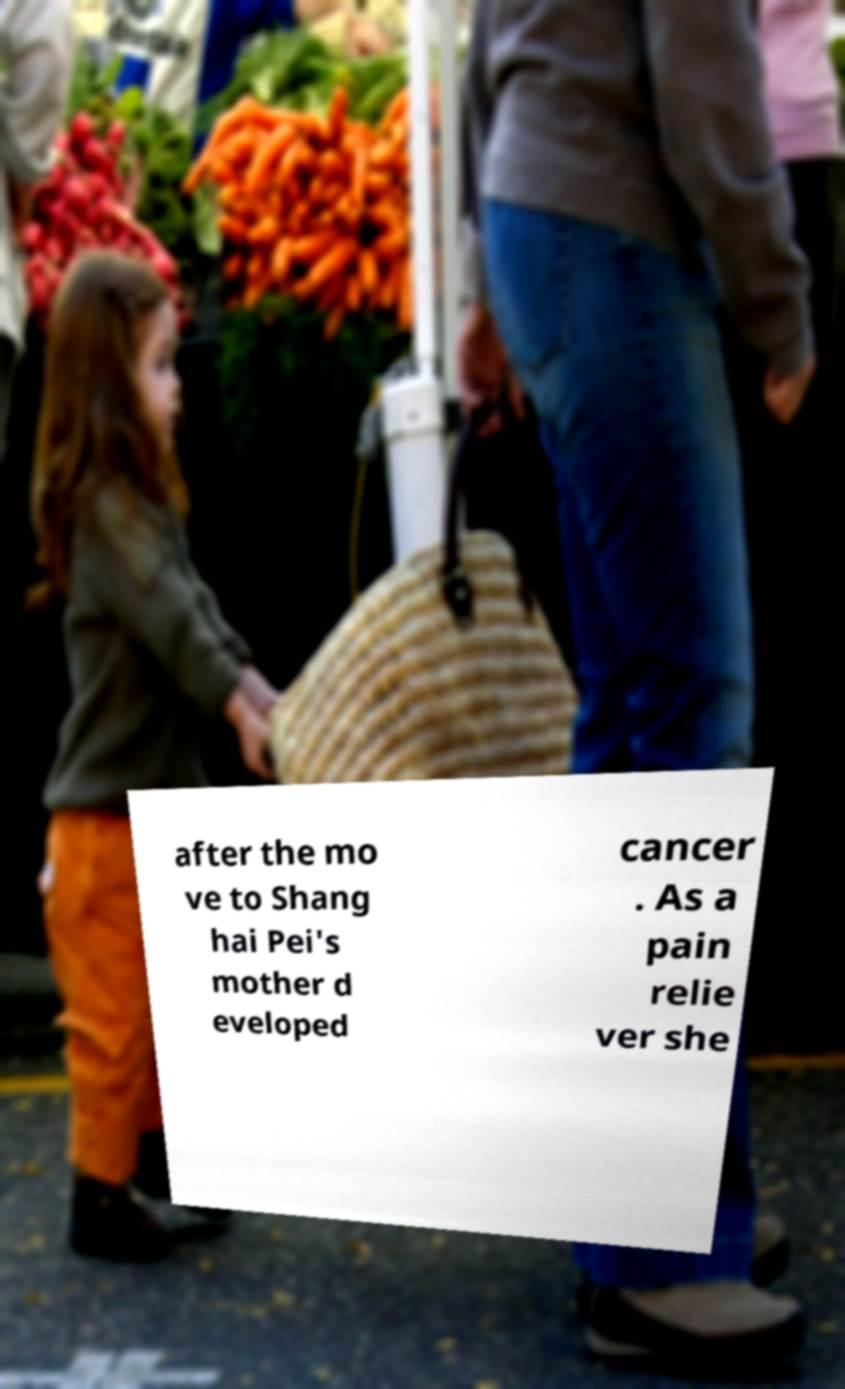For documentation purposes, I need the text within this image transcribed. Could you provide that? after the mo ve to Shang hai Pei's mother d eveloped cancer . As a pain relie ver she 